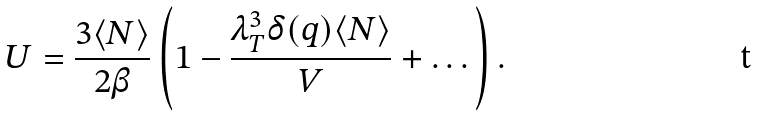Convert formula to latex. <formula><loc_0><loc_0><loc_500><loc_500>U = \frac { 3 \langle N \rangle } { 2 \beta } \left ( 1 - \frac { \lambda _ { T } ^ { 3 } \delta ( q ) \langle N \rangle } { V } + \dots \right ) .</formula> 